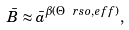<formula> <loc_0><loc_0><loc_500><loc_500>\bar { B } \approx \bar { a } ^ { \beta ( \Theta \ r s { o , e f f } ) } ,</formula> 